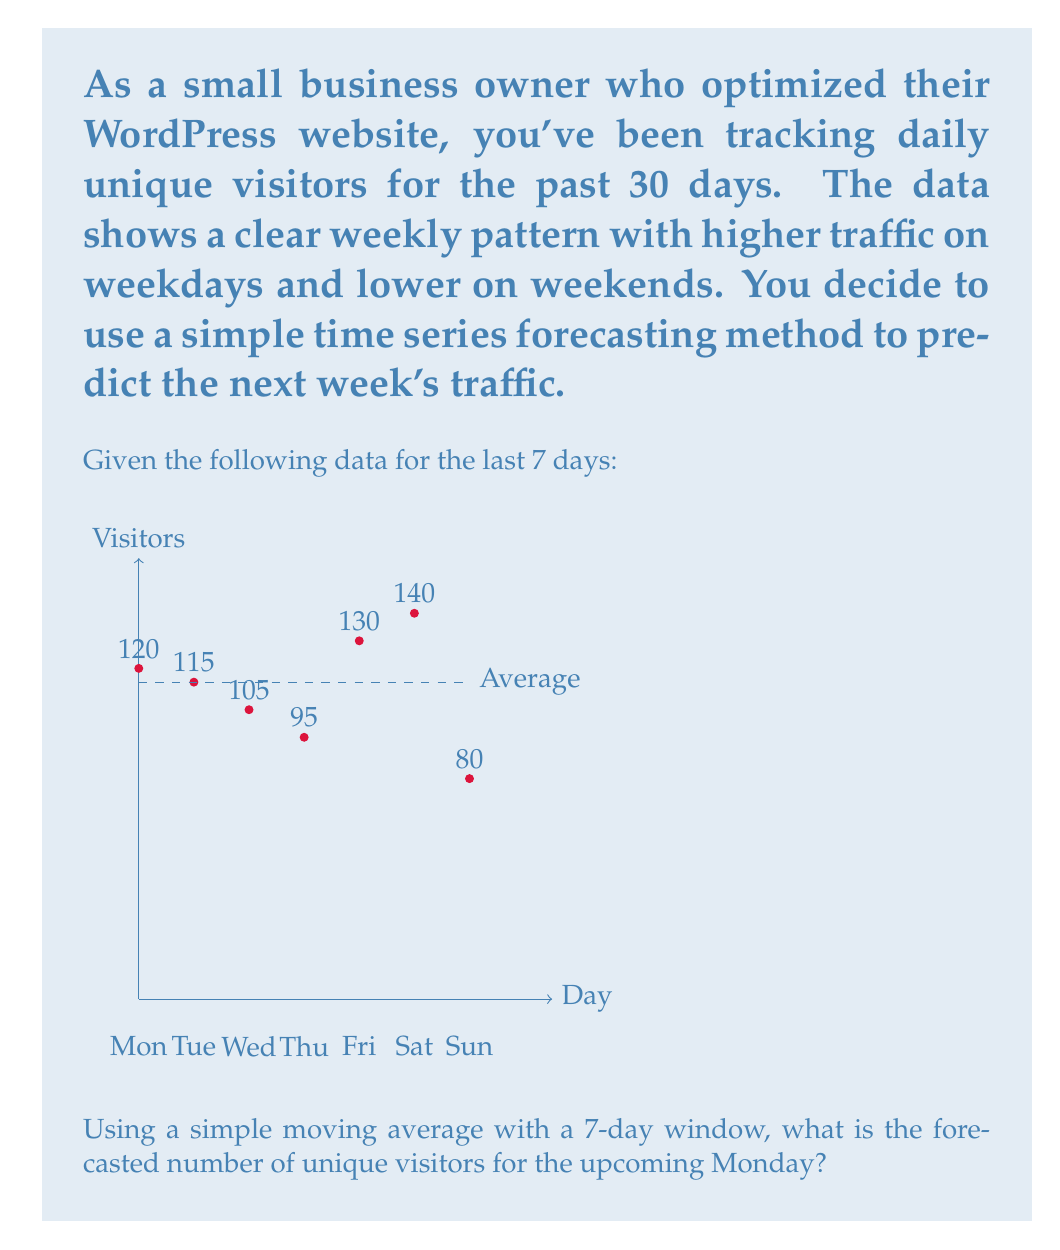Give your solution to this math problem. To solve this problem, we'll use the simple moving average (SMA) method for time series forecasting. The SMA is calculated by taking the average of a fixed number of past data points.

Step 1: Calculate the 7-day simple moving average.
SMA = (Sum of last 7 days' data) / 7

$$\text{SMA} = \frac{120 + 115 + 105 + 95 + 130 + 140 + 80}{7}$$

Step 2: Perform the calculation.
$$\text{SMA} = \frac{785}{7} = 112.14285714$$

Step 3: Round the result to the nearest whole number, as we're dealing with visitors.
Rounded SMA = 112

The SMA method assumes that the forecast for the next period is equal to the average of the previous periods. Therefore, the forecast for the upcoming Monday is 112 unique visitors.

Note: This simple method doesn't account for the weekly pattern observed in the data. For more accurate forecasts, more sophisticated time series methods like ARIMA or exponential smoothing might be more appropriate, especially when dealing with seasonal patterns.
Answer: 112 unique visitors 